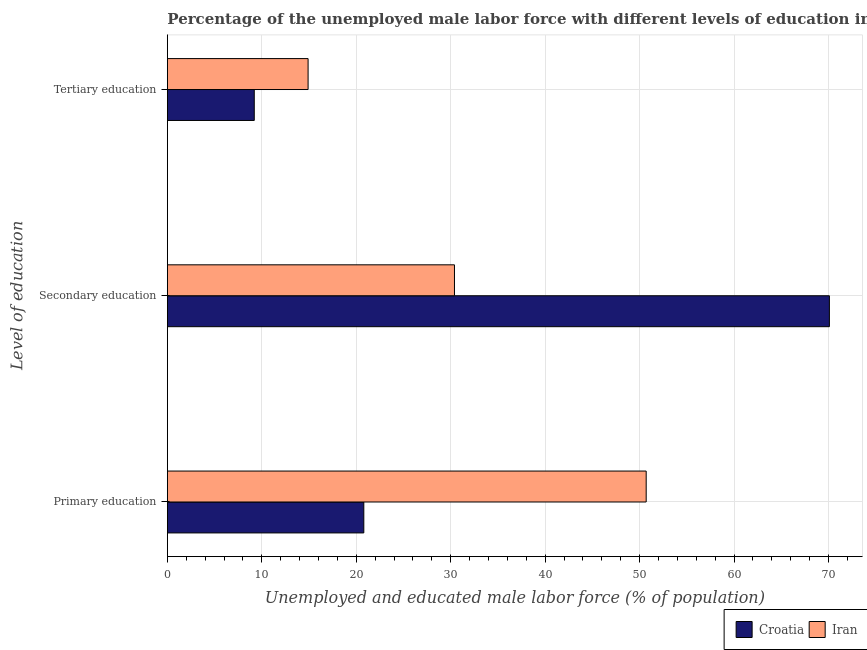How many groups of bars are there?
Offer a terse response. 3. Are the number of bars on each tick of the Y-axis equal?
Ensure brevity in your answer.  Yes. What is the label of the 1st group of bars from the top?
Keep it short and to the point. Tertiary education. What is the percentage of male labor force who received primary education in Croatia?
Provide a succinct answer. 20.8. Across all countries, what is the maximum percentage of male labor force who received secondary education?
Make the answer very short. 70.1. Across all countries, what is the minimum percentage of male labor force who received secondary education?
Provide a succinct answer. 30.4. In which country was the percentage of male labor force who received primary education maximum?
Provide a succinct answer. Iran. In which country was the percentage of male labor force who received primary education minimum?
Provide a succinct answer. Croatia. What is the total percentage of male labor force who received tertiary education in the graph?
Your response must be concise. 24.1. What is the difference between the percentage of male labor force who received tertiary education in Iran and that in Croatia?
Provide a short and direct response. 5.7. What is the difference between the percentage of male labor force who received tertiary education in Iran and the percentage of male labor force who received primary education in Croatia?
Give a very brief answer. -5.9. What is the average percentage of male labor force who received tertiary education per country?
Offer a very short reply. 12.05. What is the difference between the percentage of male labor force who received primary education and percentage of male labor force who received secondary education in Croatia?
Offer a very short reply. -49.3. In how many countries, is the percentage of male labor force who received tertiary education greater than 66 %?
Your response must be concise. 0. What is the ratio of the percentage of male labor force who received tertiary education in Croatia to that in Iran?
Make the answer very short. 0.62. Is the difference between the percentage of male labor force who received primary education in Iran and Croatia greater than the difference between the percentage of male labor force who received secondary education in Iran and Croatia?
Keep it short and to the point. Yes. What is the difference between the highest and the second highest percentage of male labor force who received primary education?
Your answer should be compact. 29.9. What is the difference between the highest and the lowest percentage of male labor force who received tertiary education?
Provide a short and direct response. 5.7. Is the sum of the percentage of male labor force who received primary education in Iran and Croatia greater than the maximum percentage of male labor force who received tertiary education across all countries?
Ensure brevity in your answer.  Yes. What does the 1st bar from the top in Secondary education represents?
Ensure brevity in your answer.  Iran. What does the 1st bar from the bottom in Primary education represents?
Offer a very short reply. Croatia. Is it the case that in every country, the sum of the percentage of male labor force who received primary education and percentage of male labor force who received secondary education is greater than the percentage of male labor force who received tertiary education?
Offer a terse response. Yes. How many countries are there in the graph?
Your response must be concise. 2. Are the values on the major ticks of X-axis written in scientific E-notation?
Keep it short and to the point. No. Does the graph contain grids?
Provide a succinct answer. Yes. How are the legend labels stacked?
Your answer should be compact. Horizontal. What is the title of the graph?
Your answer should be compact. Percentage of the unemployed male labor force with different levels of education in countries. Does "Brunei Darussalam" appear as one of the legend labels in the graph?
Your response must be concise. No. What is the label or title of the X-axis?
Your answer should be compact. Unemployed and educated male labor force (% of population). What is the label or title of the Y-axis?
Offer a terse response. Level of education. What is the Unemployed and educated male labor force (% of population) of Croatia in Primary education?
Your answer should be compact. 20.8. What is the Unemployed and educated male labor force (% of population) in Iran in Primary education?
Your answer should be compact. 50.7. What is the Unemployed and educated male labor force (% of population) of Croatia in Secondary education?
Your answer should be very brief. 70.1. What is the Unemployed and educated male labor force (% of population) in Iran in Secondary education?
Provide a succinct answer. 30.4. What is the Unemployed and educated male labor force (% of population) of Croatia in Tertiary education?
Provide a short and direct response. 9.2. What is the Unemployed and educated male labor force (% of population) of Iran in Tertiary education?
Provide a succinct answer. 14.9. Across all Level of education, what is the maximum Unemployed and educated male labor force (% of population) of Croatia?
Ensure brevity in your answer.  70.1. Across all Level of education, what is the maximum Unemployed and educated male labor force (% of population) in Iran?
Keep it short and to the point. 50.7. Across all Level of education, what is the minimum Unemployed and educated male labor force (% of population) in Croatia?
Keep it short and to the point. 9.2. Across all Level of education, what is the minimum Unemployed and educated male labor force (% of population) in Iran?
Offer a very short reply. 14.9. What is the total Unemployed and educated male labor force (% of population) in Croatia in the graph?
Give a very brief answer. 100.1. What is the total Unemployed and educated male labor force (% of population) of Iran in the graph?
Offer a very short reply. 96. What is the difference between the Unemployed and educated male labor force (% of population) in Croatia in Primary education and that in Secondary education?
Offer a terse response. -49.3. What is the difference between the Unemployed and educated male labor force (% of population) of Iran in Primary education and that in Secondary education?
Make the answer very short. 20.3. What is the difference between the Unemployed and educated male labor force (% of population) of Croatia in Primary education and that in Tertiary education?
Provide a succinct answer. 11.6. What is the difference between the Unemployed and educated male labor force (% of population) of Iran in Primary education and that in Tertiary education?
Your response must be concise. 35.8. What is the difference between the Unemployed and educated male labor force (% of population) of Croatia in Secondary education and that in Tertiary education?
Your answer should be very brief. 60.9. What is the difference between the Unemployed and educated male labor force (% of population) of Iran in Secondary education and that in Tertiary education?
Your answer should be very brief. 15.5. What is the difference between the Unemployed and educated male labor force (% of population) of Croatia in Primary education and the Unemployed and educated male labor force (% of population) of Iran in Tertiary education?
Provide a succinct answer. 5.9. What is the difference between the Unemployed and educated male labor force (% of population) of Croatia in Secondary education and the Unemployed and educated male labor force (% of population) of Iran in Tertiary education?
Provide a succinct answer. 55.2. What is the average Unemployed and educated male labor force (% of population) of Croatia per Level of education?
Keep it short and to the point. 33.37. What is the average Unemployed and educated male labor force (% of population) in Iran per Level of education?
Keep it short and to the point. 32. What is the difference between the Unemployed and educated male labor force (% of population) of Croatia and Unemployed and educated male labor force (% of population) of Iran in Primary education?
Offer a very short reply. -29.9. What is the difference between the Unemployed and educated male labor force (% of population) in Croatia and Unemployed and educated male labor force (% of population) in Iran in Secondary education?
Your answer should be compact. 39.7. What is the difference between the Unemployed and educated male labor force (% of population) in Croatia and Unemployed and educated male labor force (% of population) in Iran in Tertiary education?
Provide a succinct answer. -5.7. What is the ratio of the Unemployed and educated male labor force (% of population) of Croatia in Primary education to that in Secondary education?
Ensure brevity in your answer.  0.3. What is the ratio of the Unemployed and educated male labor force (% of population) of Iran in Primary education to that in Secondary education?
Give a very brief answer. 1.67. What is the ratio of the Unemployed and educated male labor force (% of population) in Croatia in Primary education to that in Tertiary education?
Give a very brief answer. 2.26. What is the ratio of the Unemployed and educated male labor force (% of population) of Iran in Primary education to that in Tertiary education?
Ensure brevity in your answer.  3.4. What is the ratio of the Unemployed and educated male labor force (% of population) of Croatia in Secondary education to that in Tertiary education?
Keep it short and to the point. 7.62. What is the ratio of the Unemployed and educated male labor force (% of population) of Iran in Secondary education to that in Tertiary education?
Provide a succinct answer. 2.04. What is the difference between the highest and the second highest Unemployed and educated male labor force (% of population) in Croatia?
Ensure brevity in your answer.  49.3. What is the difference between the highest and the second highest Unemployed and educated male labor force (% of population) in Iran?
Give a very brief answer. 20.3. What is the difference between the highest and the lowest Unemployed and educated male labor force (% of population) in Croatia?
Give a very brief answer. 60.9. What is the difference between the highest and the lowest Unemployed and educated male labor force (% of population) of Iran?
Offer a very short reply. 35.8. 